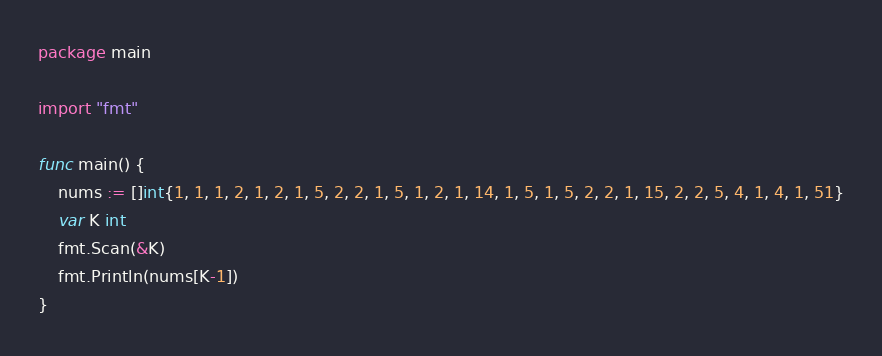<code> <loc_0><loc_0><loc_500><loc_500><_Go_>package main

import "fmt"

func main() {
	nums := []int{1, 1, 1, 2, 1, 2, 1, 5, 2, 2, 1, 5, 1, 2, 1, 14, 1, 5, 1, 5, 2, 2, 1, 15, 2, 2, 5, 4, 1, 4, 1, 51}
	var K int
	fmt.Scan(&K)
	fmt.Println(nums[K-1])
}
</code> 